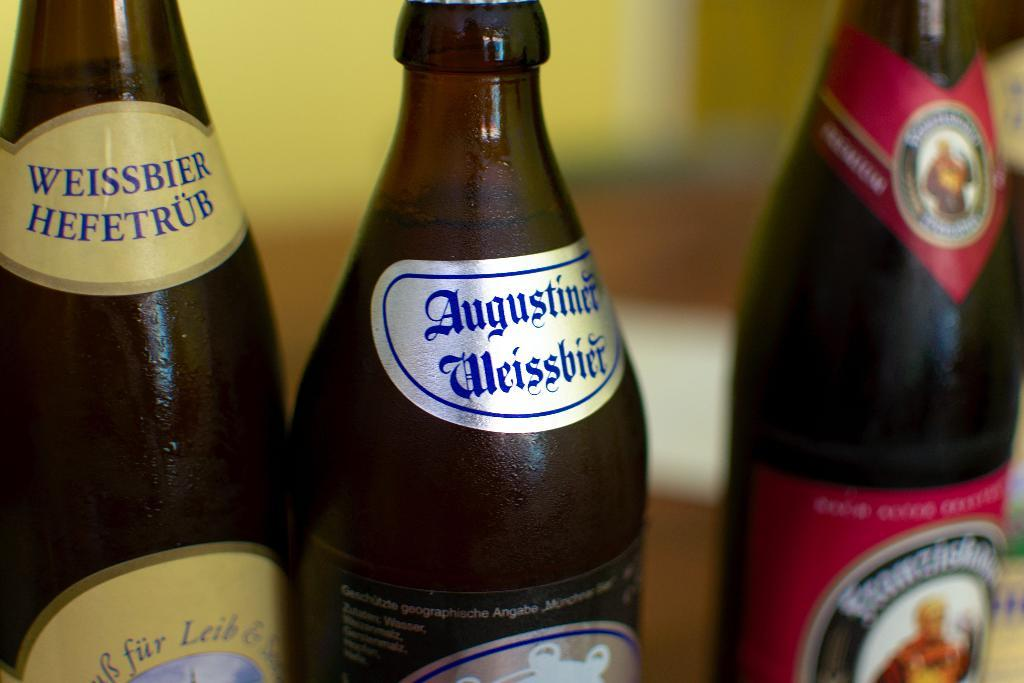<image>
Provide a brief description of the given image. close up of several bottles of beer includes Weissbier Hefetrub 